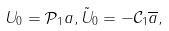Convert formula to latex. <formula><loc_0><loc_0><loc_500><loc_500>U _ { 0 } = \mathcal { P } _ { 1 } a , \tilde { U } _ { 0 } = - \mathcal { C } _ { 1 } \overline { a } ,</formula> 